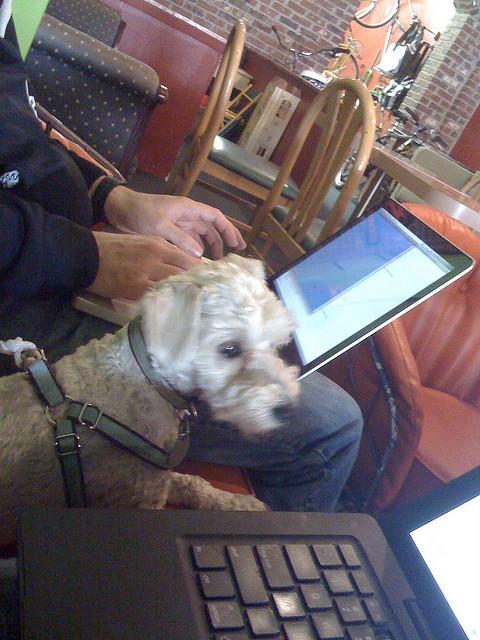Is the dog wearing a harness?
Quick response, please. Yes. What is this dog looking at?
Answer briefly. Laptop. Is the dog using a laptop also?
Short answer required. No. 